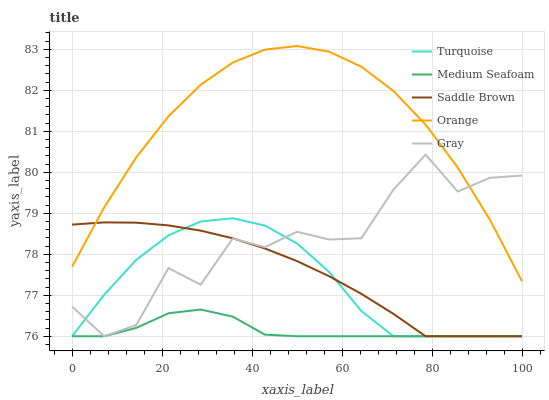Does Medium Seafoam have the minimum area under the curve?
Answer yes or no. Yes. Does Orange have the maximum area under the curve?
Answer yes or no. Yes. Does Gray have the minimum area under the curve?
Answer yes or no. No. Does Gray have the maximum area under the curve?
Answer yes or no. No. Is Saddle Brown the smoothest?
Answer yes or no. Yes. Is Gray the roughest?
Answer yes or no. Yes. Is Turquoise the smoothest?
Answer yes or no. No. Is Turquoise the roughest?
Answer yes or no. No. Does Gray have the lowest value?
Answer yes or no. Yes. Does Orange have the highest value?
Answer yes or no. Yes. Does Gray have the highest value?
Answer yes or no. No. Is Turquoise less than Orange?
Answer yes or no. Yes. Is Orange greater than Turquoise?
Answer yes or no. Yes. Does Saddle Brown intersect Orange?
Answer yes or no. Yes. Is Saddle Brown less than Orange?
Answer yes or no. No. Is Saddle Brown greater than Orange?
Answer yes or no. No. Does Turquoise intersect Orange?
Answer yes or no. No. 